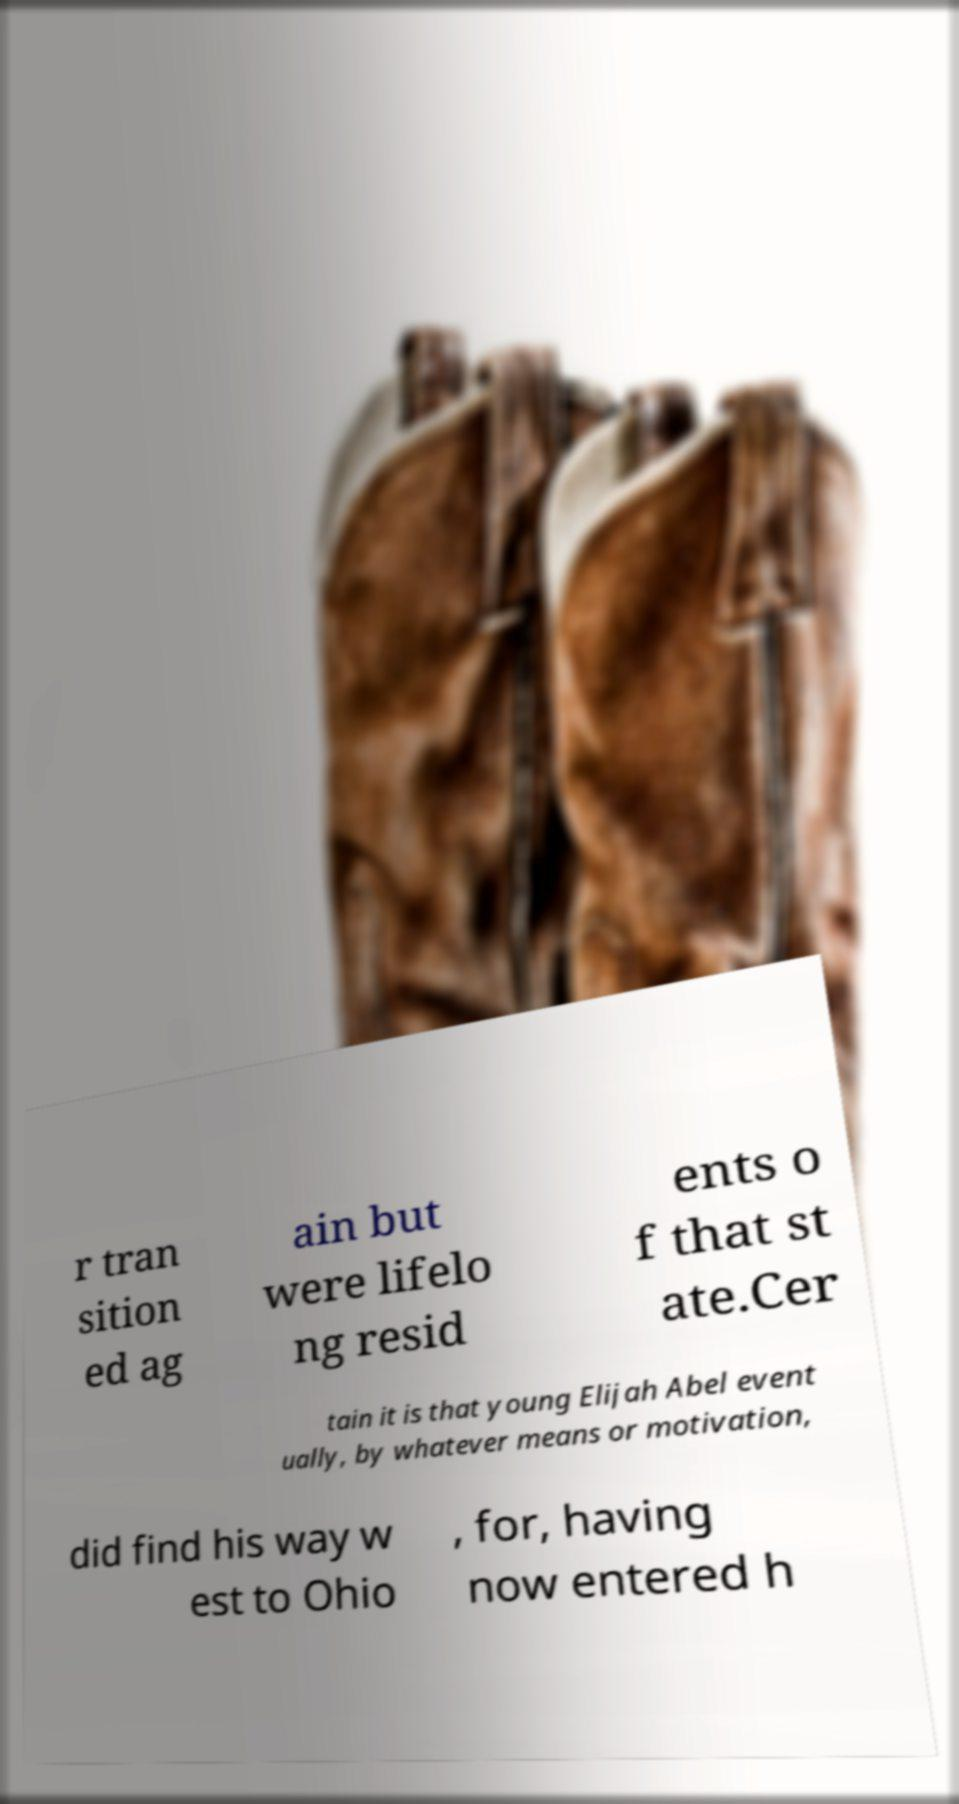I need the written content from this picture converted into text. Can you do that? r tran sition ed ag ain but were lifelo ng resid ents o f that st ate.Cer tain it is that young Elijah Abel event ually, by whatever means or motivation, did find his way w est to Ohio , for, having now entered h 